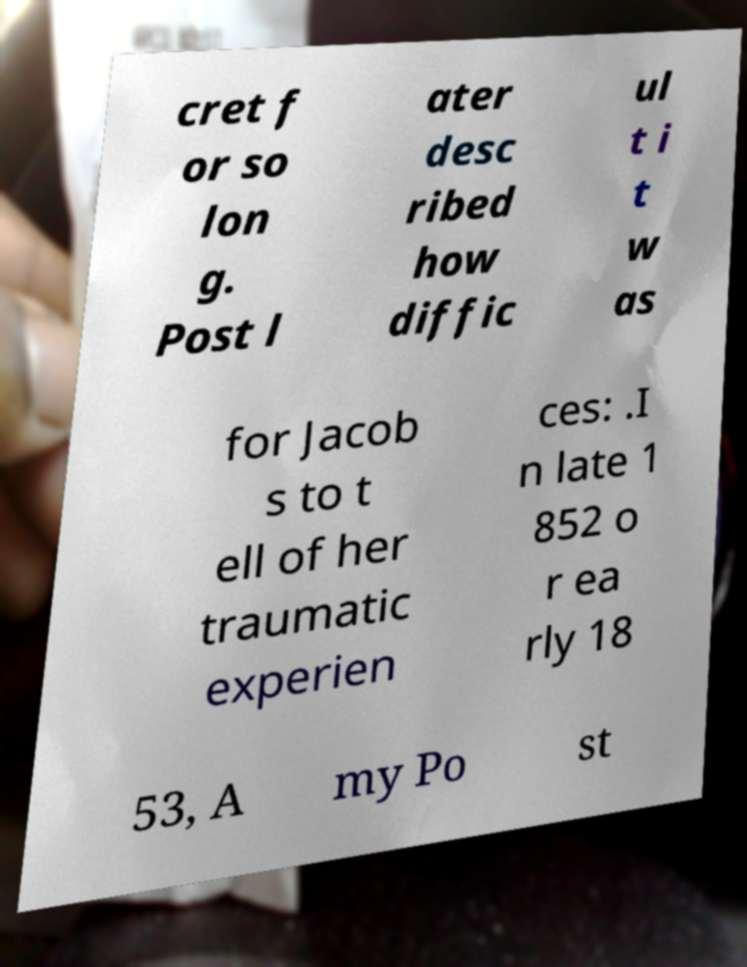Could you extract and type out the text from this image? cret f or so lon g. Post l ater desc ribed how diffic ul t i t w as for Jacob s to t ell of her traumatic experien ces: .I n late 1 852 o r ea rly 18 53, A my Po st 